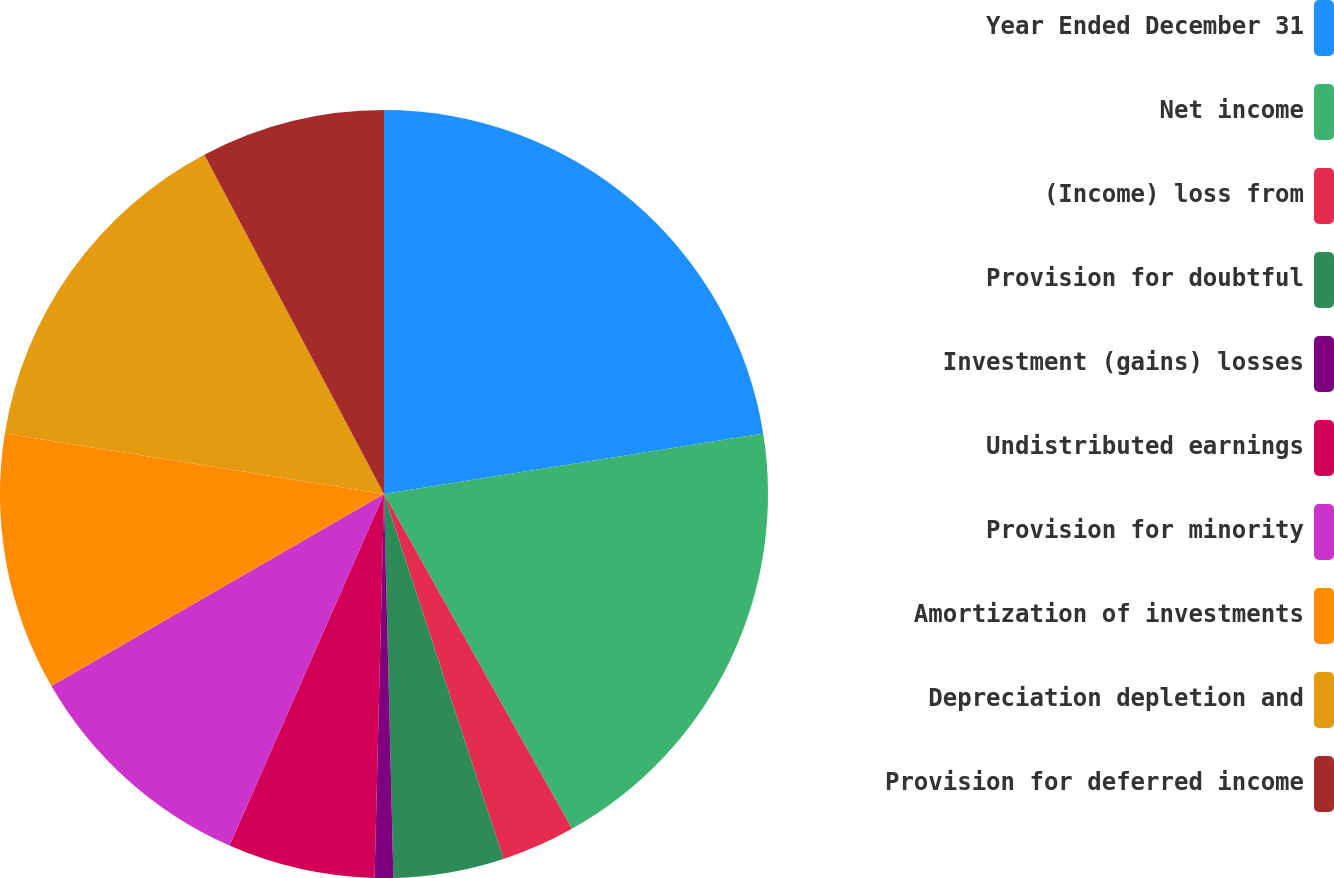<chart> <loc_0><loc_0><loc_500><loc_500><pie_chart><fcel>Year Ended December 31<fcel>Net income<fcel>(Income) loss from<fcel>Provision for doubtful<fcel>Investment (gains) losses<fcel>Undistributed earnings<fcel>Provision for minority<fcel>Amortization of investments<fcel>Depreciation depletion and<fcel>Provision for deferred income<nl><fcel>22.48%<fcel>19.38%<fcel>3.1%<fcel>4.65%<fcel>0.78%<fcel>6.2%<fcel>10.08%<fcel>10.85%<fcel>14.73%<fcel>7.75%<nl></chart> 